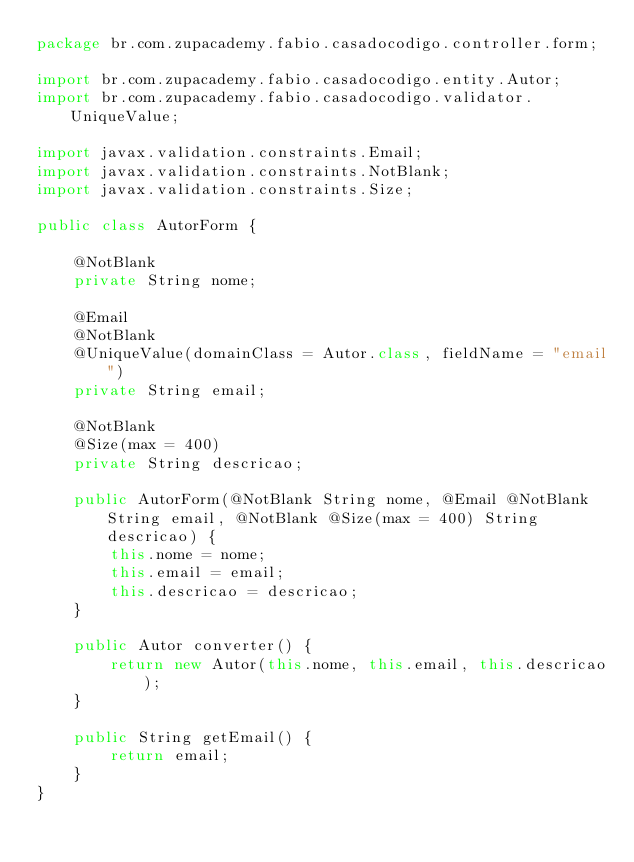<code> <loc_0><loc_0><loc_500><loc_500><_Java_>package br.com.zupacademy.fabio.casadocodigo.controller.form;

import br.com.zupacademy.fabio.casadocodigo.entity.Autor;
import br.com.zupacademy.fabio.casadocodigo.validator.UniqueValue;

import javax.validation.constraints.Email;
import javax.validation.constraints.NotBlank;
import javax.validation.constraints.Size;

public class AutorForm {

    @NotBlank
    private String nome;

    @Email
    @NotBlank
    @UniqueValue(domainClass = Autor.class, fieldName = "email")
    private String email;

    @NotBlank
    @Size(max = 400)
    private String descricao;

    public AutorForm(@NotBlank String nome, @Email @NotBlank String email, @NotBlank @Size(max = 400) String descricao) {
        this.nome = nome;
        this.email = email;
        this.descricao = descricao;
    }

    public Autor converter() {
        return new Autor(this.nome, this.email, this.descricao);
    }

    public String getEmail() {
        return email;
    }
}
</code> 